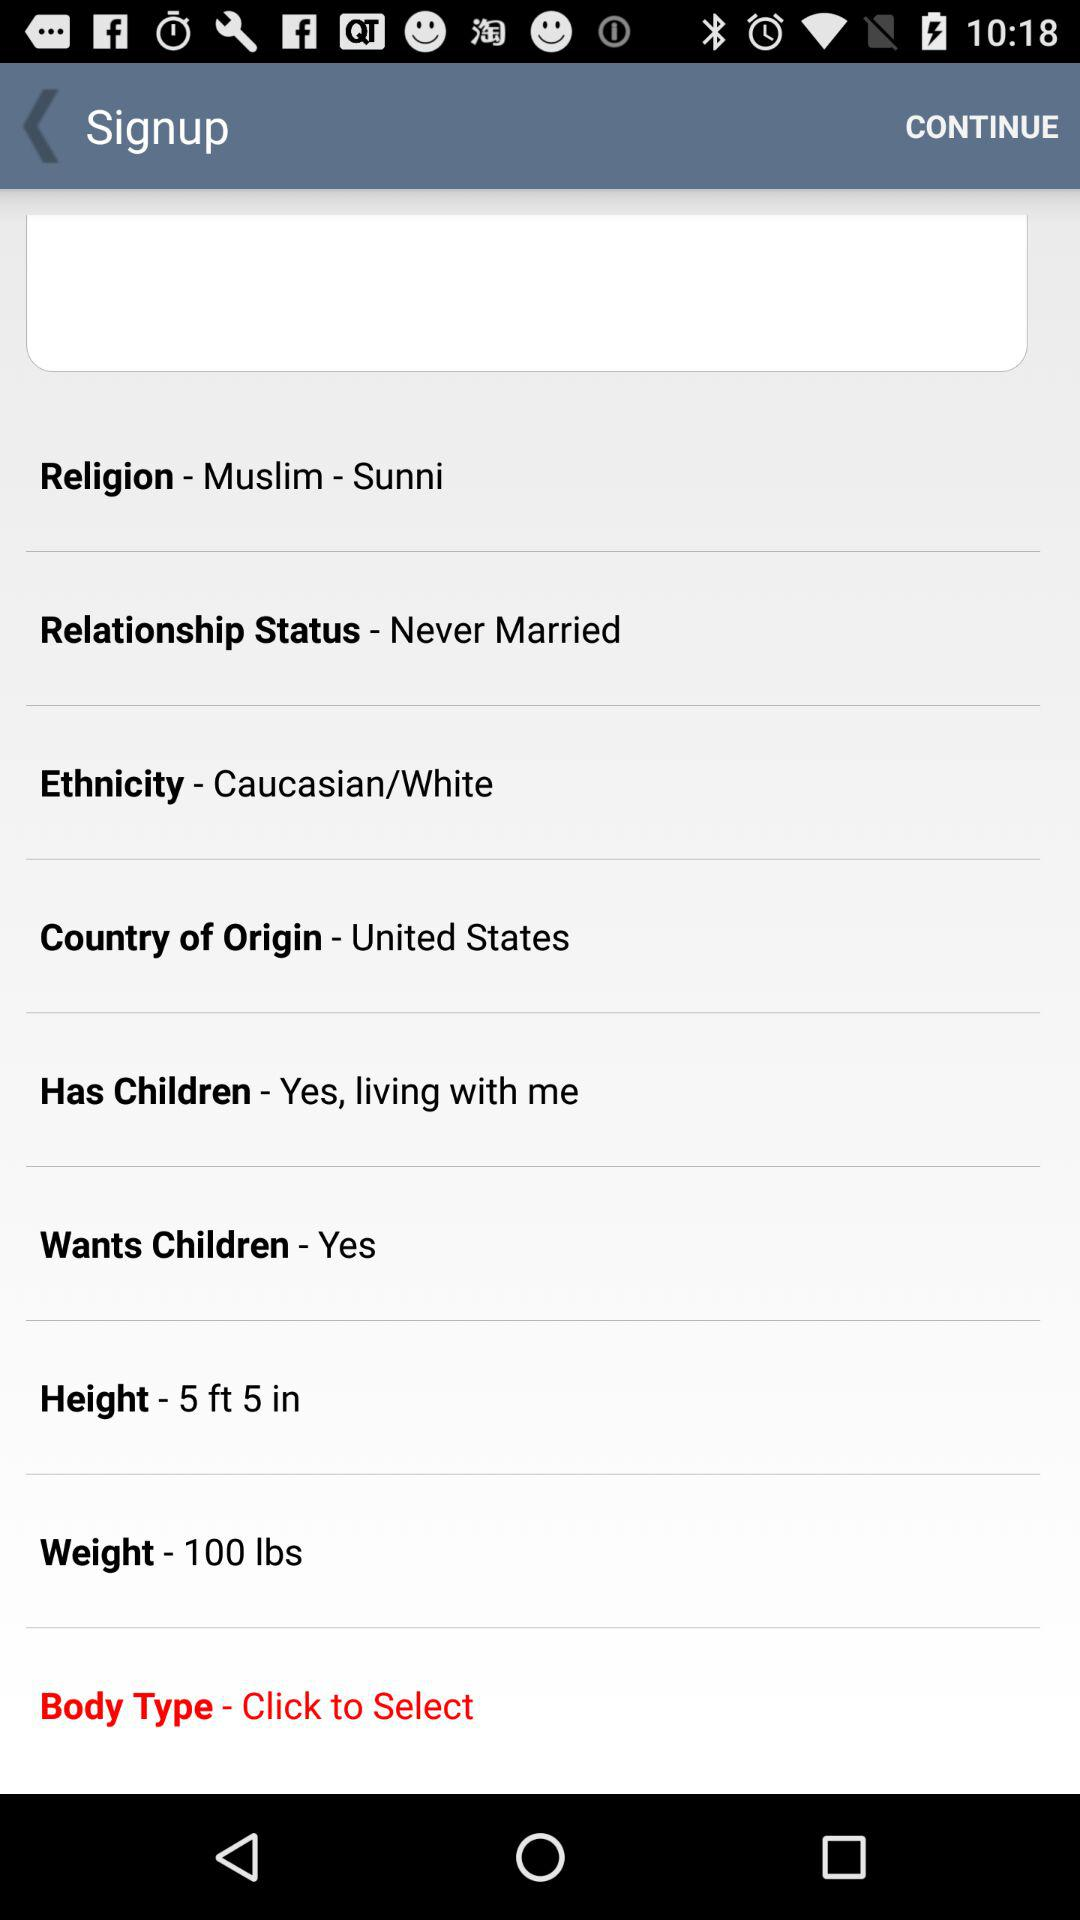What is the weight? The weight is 100 lbs. 